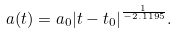Convert formula to latex. <formula><loc_0><loc_0><loc_500><loc_500>a ( t ) = a _ { 0 } { | t - t _ { 0 } | } ^ { \frac { 1 } { - 2 . 1 1 9 5 } } .</formula> 